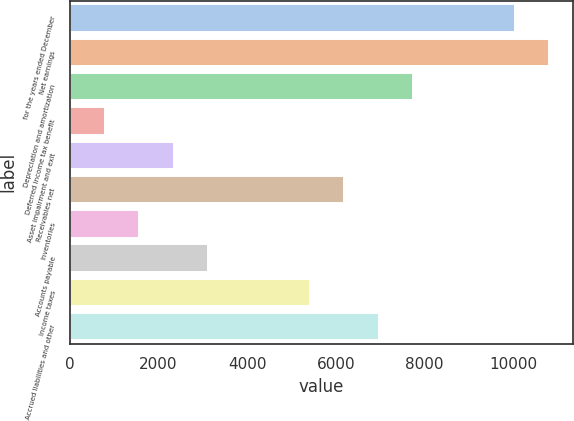Convert chart. <chart><loc_0><loc_0><loc_500><loc_500><bar_chart><fcel>for the years ended December<fcel>Net earnings<fcel>Depreciation and amortization<fcel>Deferred income tax benefit<fcel>Asset impairment and exit<fcel>Receivables net<fcel>Inventories<fcel>Accounts payable<fcel>Income taxes<fcel>Accrued liabilities and other<nl><fcel>10052<fcel>10823<fcel>7739<fcel>800<fcel>2342<fcel>6197<fcel>1571<fcel>3113<fcel>5426<fcel>6968<nl></chart> 